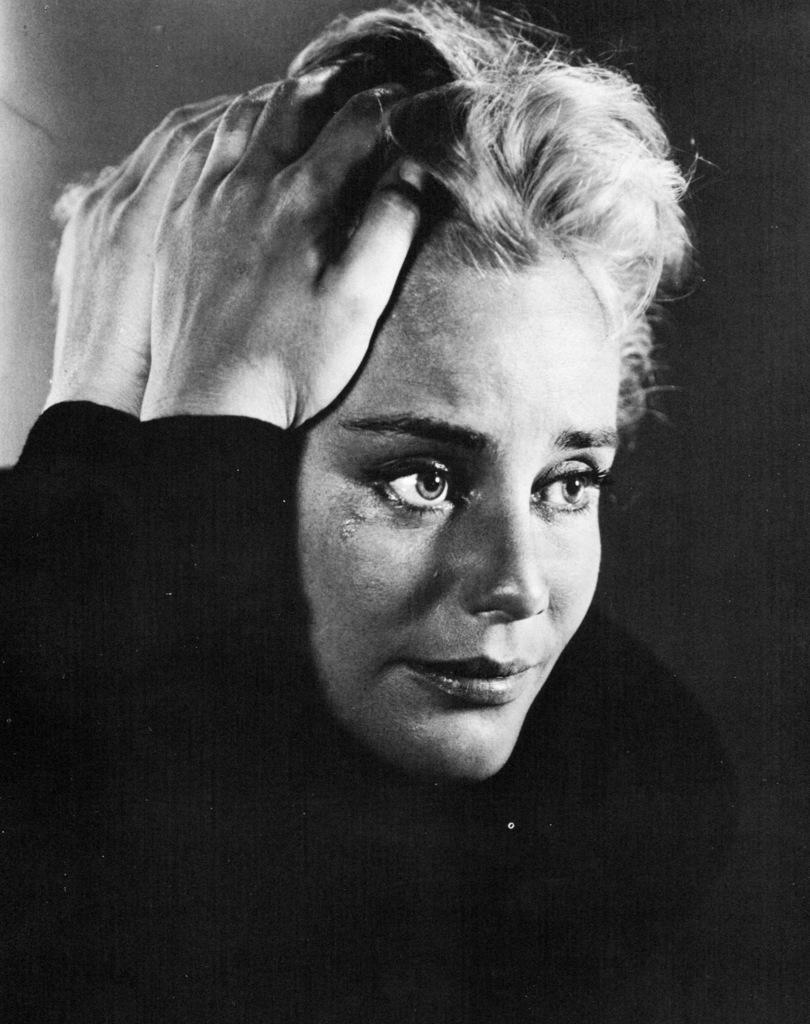What is the color scheme of the image? The image is black and white. Can you describe the main subject of the image? There is a woman in the image. What type of sand can be seen in the image? There is no sand present in the image; it is a black and white image featuring a woman. 